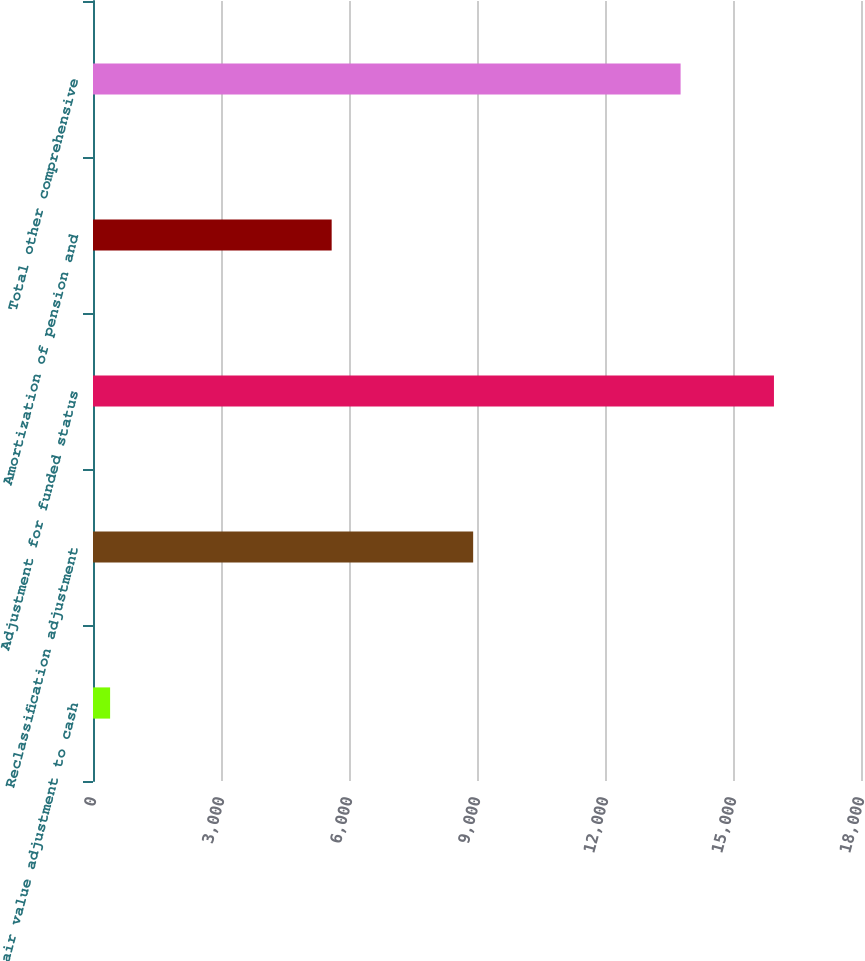Convert chart to OTSL. <chart><loc_0><loc_0><loc_500><loc_500><bar_chart><fcel>Fair value adjustment to cash<fcel>Reclassification adjustment<fcel>Adjustment for funded status<fcel>Amortization of pension and<fcel>Total other comprehensive<nl><fcel>401<fcel>8910<fcel>15960<fcel>5593.8<fcel>13772<nl></chart> 